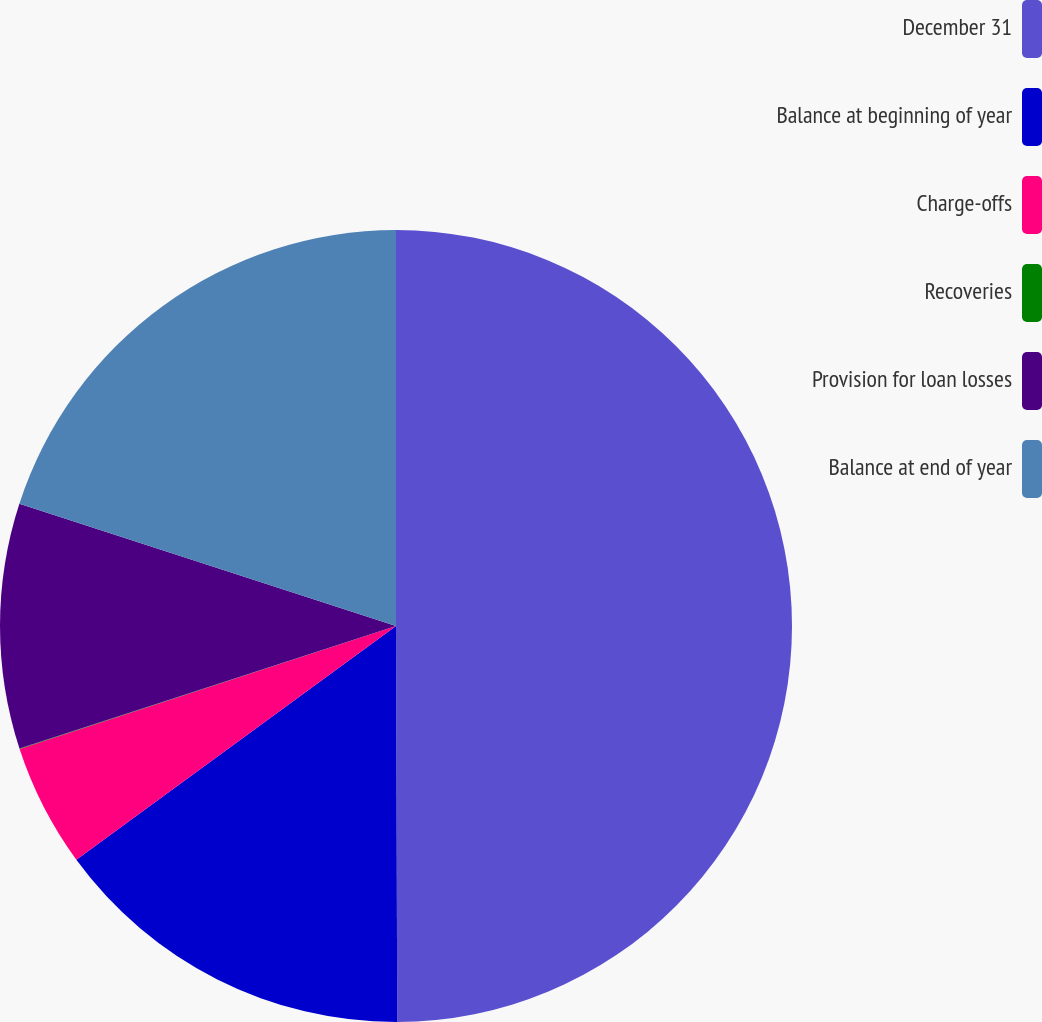Convert chart to OTSL. <chart><loc_0><loc_0><loc_500><loc_500><pie_chart><fcel>December 31<fcel>Balance at beginning of year<fcel>Charge-offs<fcel>Recoveries<fcel>Provision for loan losses<fcel>Balance at end of year<nl><fcel>49.95%<fcel>15.0%<fcel>5.02%<fcel>0.02%<fcel>10.01%<fcel>20.0%<nl></chart> 